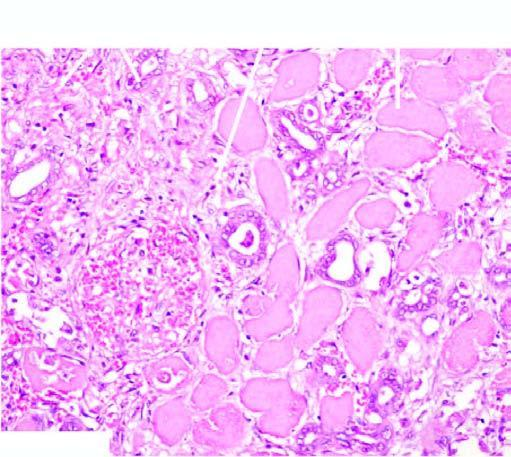what do renal tubules and glomeruli show?
Answer the question using a single word or phrase. Typical coagulative necrosis 